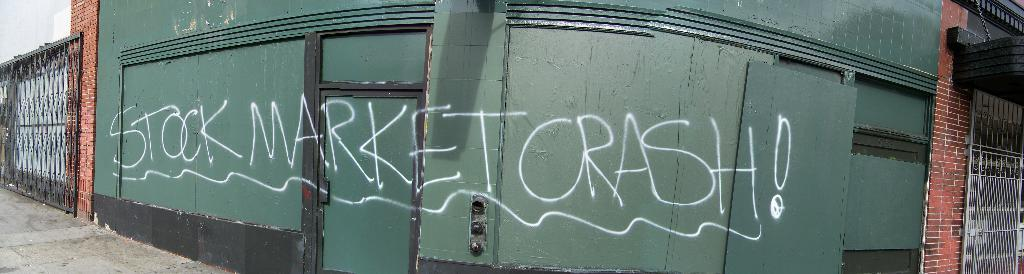What type of image is shown in the picture? The image appears to be a panorama shot of a building. What architectural features can be seen on the building? There are grills on both sides of the building. What is on the green wall of the building? There is text on the green wall of the building. How many dimes can be seen on the building? There are no dimes visible on the building. 